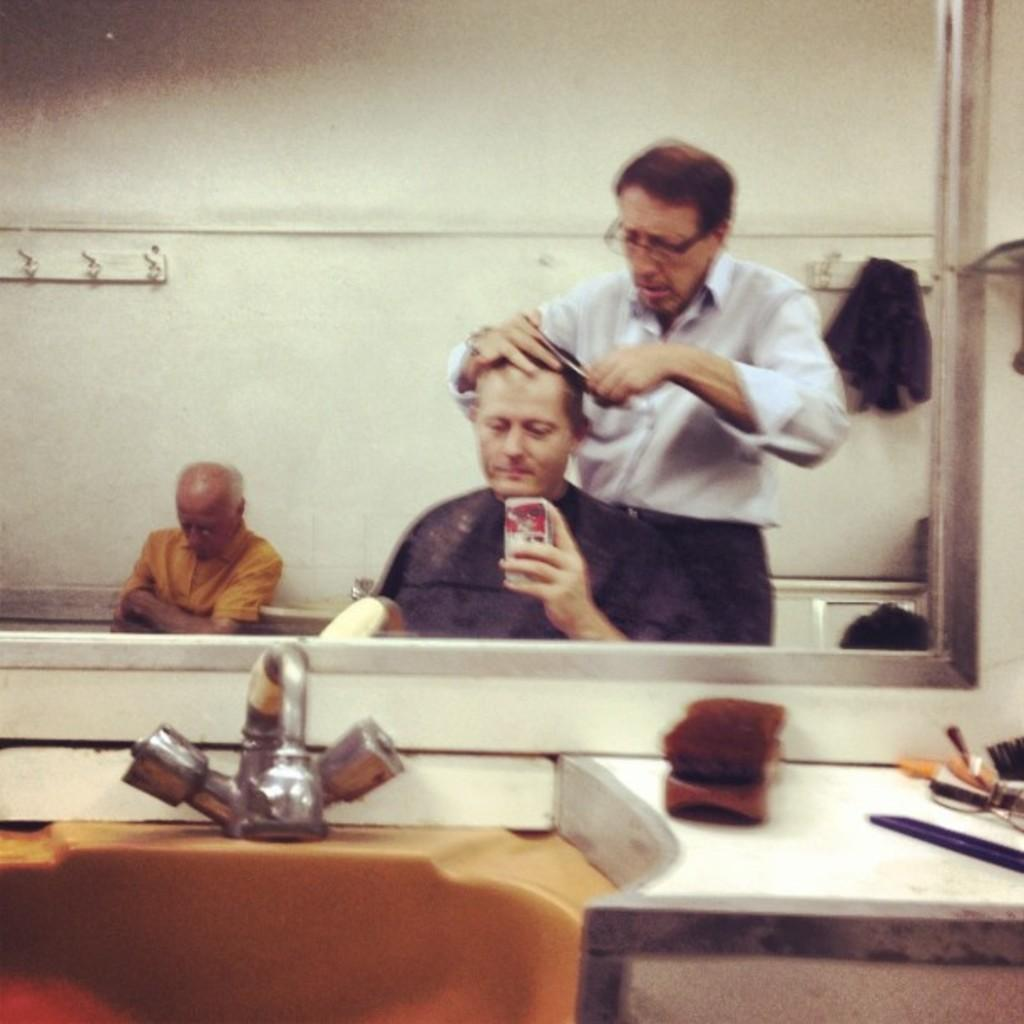What object is present in the image that allows for reflection? There is a mirror in the image. What can be seen in the mirror's reflection? The reflection of three persons is visible in the mirror. What else is present at the bottom of the image? There are objects present at the bottom of the image. What type of horn can be heard in the image? There is no horn present in the image, and therefore no sound can be heard. Can you tell me how many grandmothers are visible in the image? There is no mention of a grandmother or any family members in the image, so it is impossible to determine the number of grandmothers present. 